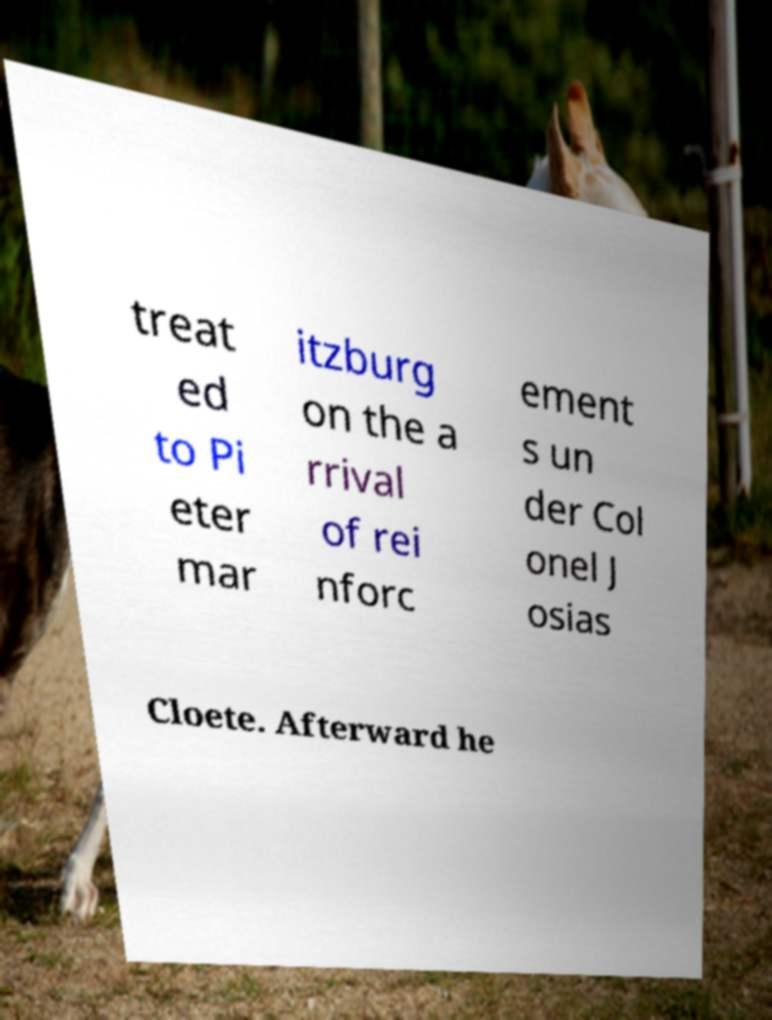Can you read and provide the text displayed in the image?This photo seems to have some interesting text. Can you extract and type it out for me? treat ed to Pi eter mar itzburg on the a rrival of rei nforc ement s un der Col onel J osias Cloete. Afterward he 